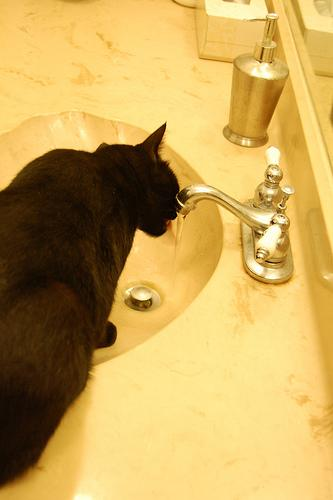Identify the color of the cat and its most distinctive feature in the image. The cat is black and has thick, furry fur. What is the primary activity that the cat is performing in the image? The cat is drinking water from the faucet in the bathroom sink. Provide a brief, general description of the scene captured in the image. The image features a black cat drinking water from a silver faucet in a bathroom with a white marble countertop and various bathroom accessories. Explain the type and appearance of the bathroom sink and its hardware. The sink has a scalloped edge, with brushed silver hardware, including the sink faucet, handles, and plug. What kind of counter is present in the bathroom and what are some items on it? It is a white marble bathroom counter with a tissue box, soap dispenser, and faucet hardware. Which items can be found on the counter? List them in the order they appear in the image. White marble bathroom counter, tissue box, liquid soap dispenser, and faucet. What color is the bathroom counter, and what kind of material does it seem to be made from? The bathroom counter is white, and it appears to be made of marble. Formulate a question about the cat's next moves after it has finished drinking in this scene. What will the cat do once it has quenched its thirst from the sink faucet? Which direction is the water coming from and what is the cat doing with it? The water is coming from the faucet, and the cat is drinking it. Where is the cat drinking water from, and provide a brief description of the source. The cat is drinking water from the bathroom sink faucet, which has brushed silver hardware and running water. Enumerate the various silver items visible in the image. Sink faucet, faucet handles, sink plug, soap dispenser, and tissue box holder. Identify the ongoing activity in the image. A black cat is drinking water from the bathroom sink faucet. Create a vivid caption that unites humor, and a description of the cat in the image. Mysterious black feline conquers the bathroom sink with its pointy ears and charming pink tongue! Invent a dialogue between the cat and the faucet, drawing inspiration from the activities taking place in the image. Cat: "You're an intriguing contraption, always gushing water when I least expect it." Are there any tissues visible in the image? If so, can you indicate where they might be located? Yes, there is a cardboard tissue box on the bathroom counter. Is the cat drinking water from the faucet or a bowl? Choose the correct option. (A) Faucet (B) Bowl (A) Faucet Describe the sink's hardware and the appearance of the bathroom counter in detail. The sink has brushed silver hardware, including the faucet handles, plug, and soap dispenser. The bathroom counter is made of white marble. Write a haiku that encapsulates the essence of the image. Black cat at the sink, Can you detect any distinct facial features of the cat, such as its tongue or ears? The cat has pointy ears and a pink tongue. Examine the diagram and describe the layout of the bathroom sink and its components. The bathroom sink has a scalloped edge and oval shape, with brushed silver faucet hardware, a silver sink plug, and a faucet with a left and right handle. A soap dispenser and tissue box are also present on the counter. Identify the items in the image that serve a hygienic purpose and describe their appearance. The liquid soap dispenser is silver, and the white cardboard tissue box is on the bathroom counter. Generate a description of the scene that an author in the 19th century might compose. In the quaint and elegant marble-adorned washroom, a curious ebony feline indulges in the fresh nectar flowing from the extravagant brushed silver spigot. Analyze the image and determine if the sink faucet is on or off. The sink faucet is on, with water running from it. Which items are dispensers in the image and what are their colors? There is a silver liquid soap dispenser and a silver tissue box holder. What can you tell about the cat in the image? The cat is black, has thick fur, pointy ears, and a pink tongue. It is drinking water from the sink faucet. 